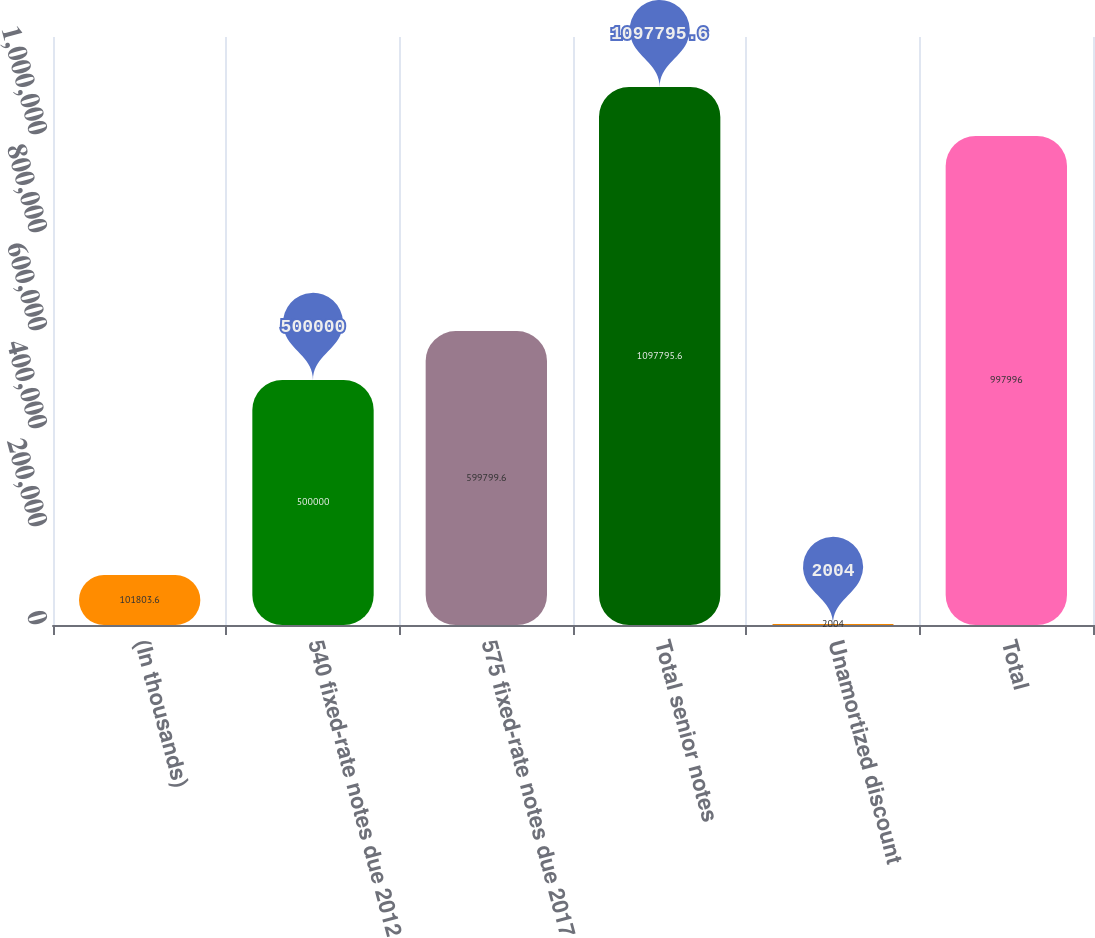Convert chart to OTSL. <chart><loc_0><loc_0><loc_500><loc_500><bar_chart><fcel>(In thousands)<fcel>540 fixed-rate notes due 2012<fcel>575 fixed-rate notes due 2017<fcel>Total senior notes<fcel>Unamortized discount<fcel>Total<nl><fcel>101804<fcel>500000<fcel>599800<fcel>1.0978e+06<fcel>2004<fcel>997996<nl></chart> 